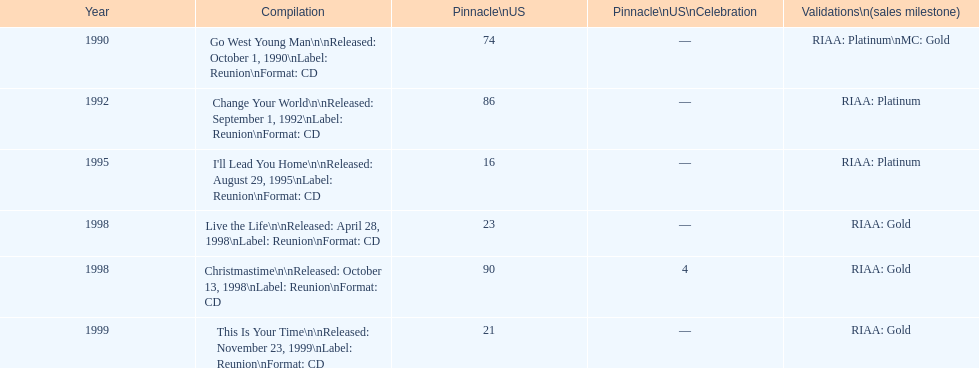What was the first michael w smith album? Go West Young Man. 